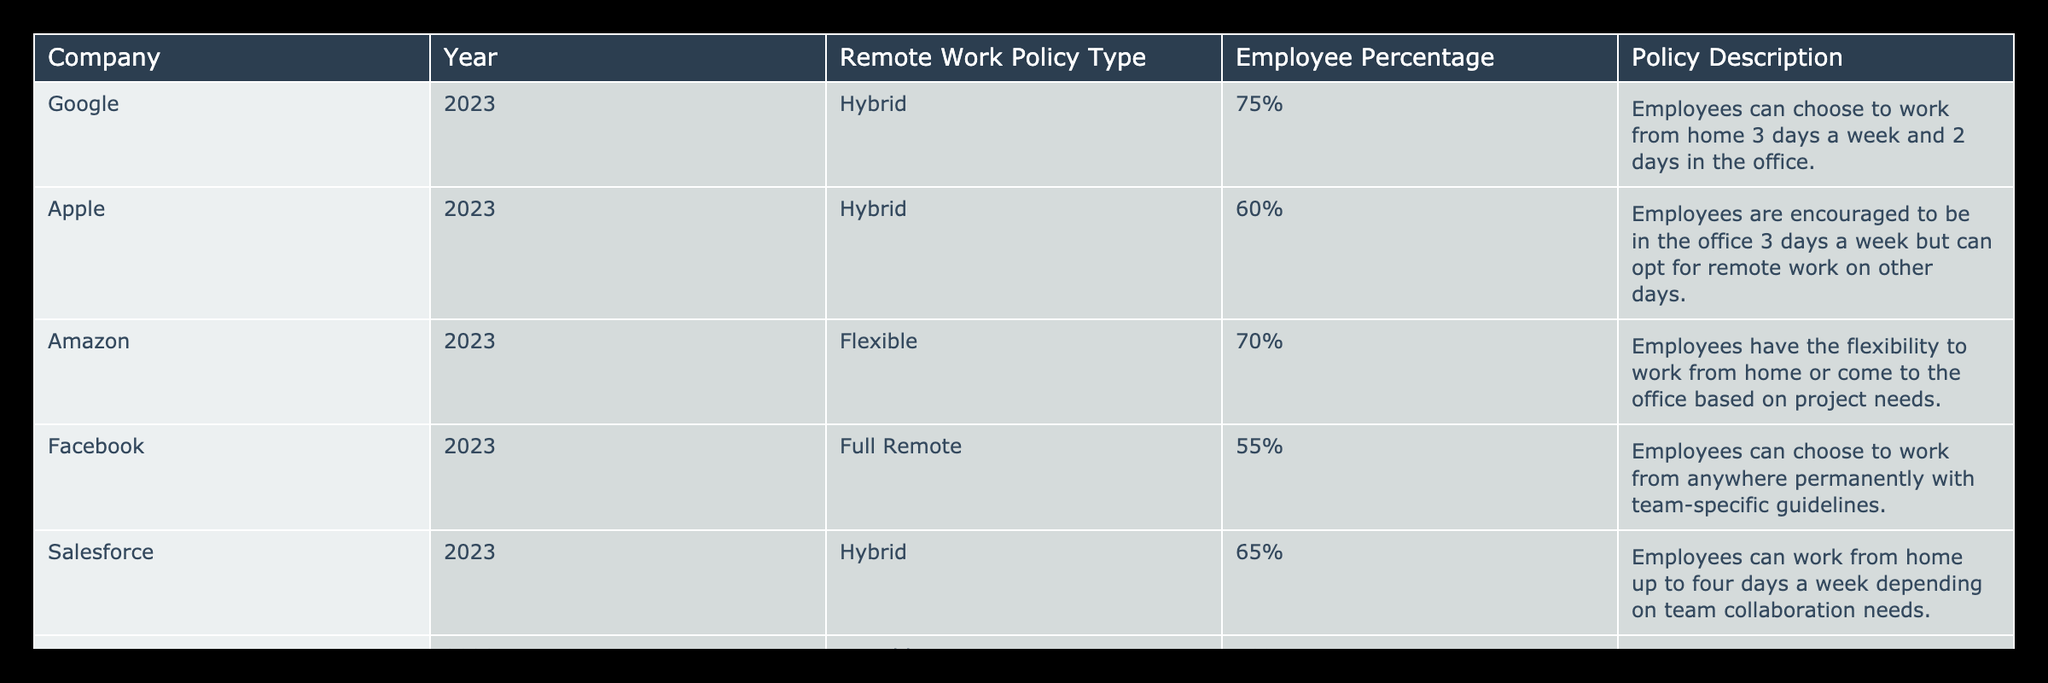What remote work policy type has the highest employee percentage? By examining the "Employee Percentage" column, I notice that "Hybrid" with "75%" is the highest percentage. This pertains to Google, indicating that their policy allows for a more flexible work arrangement.
Answer: Hybrid Which company has the policy that allows employees to work remotely for five days a week? The table shows that Slack Technologies has a Hybrid policy that permits remote work for up to five days a week. This indicates a strong emphasis on flexibility.
Answer: Slack Technologies Is IBM's remote work policy flexible? Looking at the table, IBM has a "Variable" remote work policy, which states that employees are assessed quarterly for eligibility based on performance. This suggests that it may not be flexible, as it's contingent on evaluations.
Answer: No What is the average employee percentage for companies with a Hybrid policy? We need to find the employee percentages for the companies with a Hybrid policy: Google (75%), Apple (60%), Salesforce (65%), and Slack Technologies (70%). We sum these: 75 + 60 + 65 + 70 = 270, and divide by 4 to find the average: 270/4 = 67.5%.
Answer: 67.5% Which companies have a lower employee percentage than Amazon? Amazon has a "Flexible" policy with a percentage of 70%. Reviewing the table, Facebook (55%), IBM (40%), and Slack Technologies (70%) either meet or fall below this threshold. The only company with a lower percentage is Facebook and IBM.
Answer: Facebook and IBM What percentage of employees at Apple can choose to work from home? The table states that Apple encourages employees to be in the office 3 days a week but allows remote work on other days. This indicates that 40% of employees can opt to work from home for 2 days weekly on average basis.
Answer: 40% Do all the companies listed offer a hybrid or flexible remote work policy? Reviewing the data reveals that all companies have either a Hybrid or Flexible policy except for IBM, which follows a Variable policy. Therefore, not all companies strictly adhere to Hybrid or Flexible classifications.
Answer: No How many companies allow permanent remote work? The table indicates that only Facebook explicitly states a Full Remote policy with the option to work from anywhere permanently while adhering to team-specific guidelines. Hence, there is one company with this option.
Answer: 1 